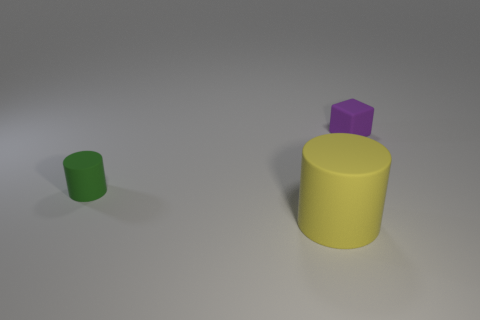What number of purple matte cubes have the same size as the purple thing?
Provide a succinct answer. 0. What number of tiny objects are both to the right of the yellow object and in front of the purple thing?
Provide a succinct answer. 0. There is a matte thing that is behind the green cylinder; is it the same size as the small green rubber thing?
Provide a succinct answer. Yes. Are there any rubber things of the same color as the large rubber cylinder?
Your response must be concise. No. There is a green thing that is the same material as the tiny purple cube; what is its size?
Offer a very short reply. Small. Is the number of large yellow objects that are in front of the tiny purple matte block greater than the number of tiny green matte objects on the right side of the large yellow object?
Your answer should be compact. Yes. What number of other things are made of the same material as the big thing?
Provide a succinct answer. 2. Do the tiny thing that is in front of the small purple object and the tiny purple block have the same material?
Ensure brevity in your answer.  Yes. The green thing has what shape?
Your answer should be compact. Cylinder. Are there more big cylinders that are on the left side of the small rubber block than tiny red shiny cylinders?
Offer a terse response. Yes. 